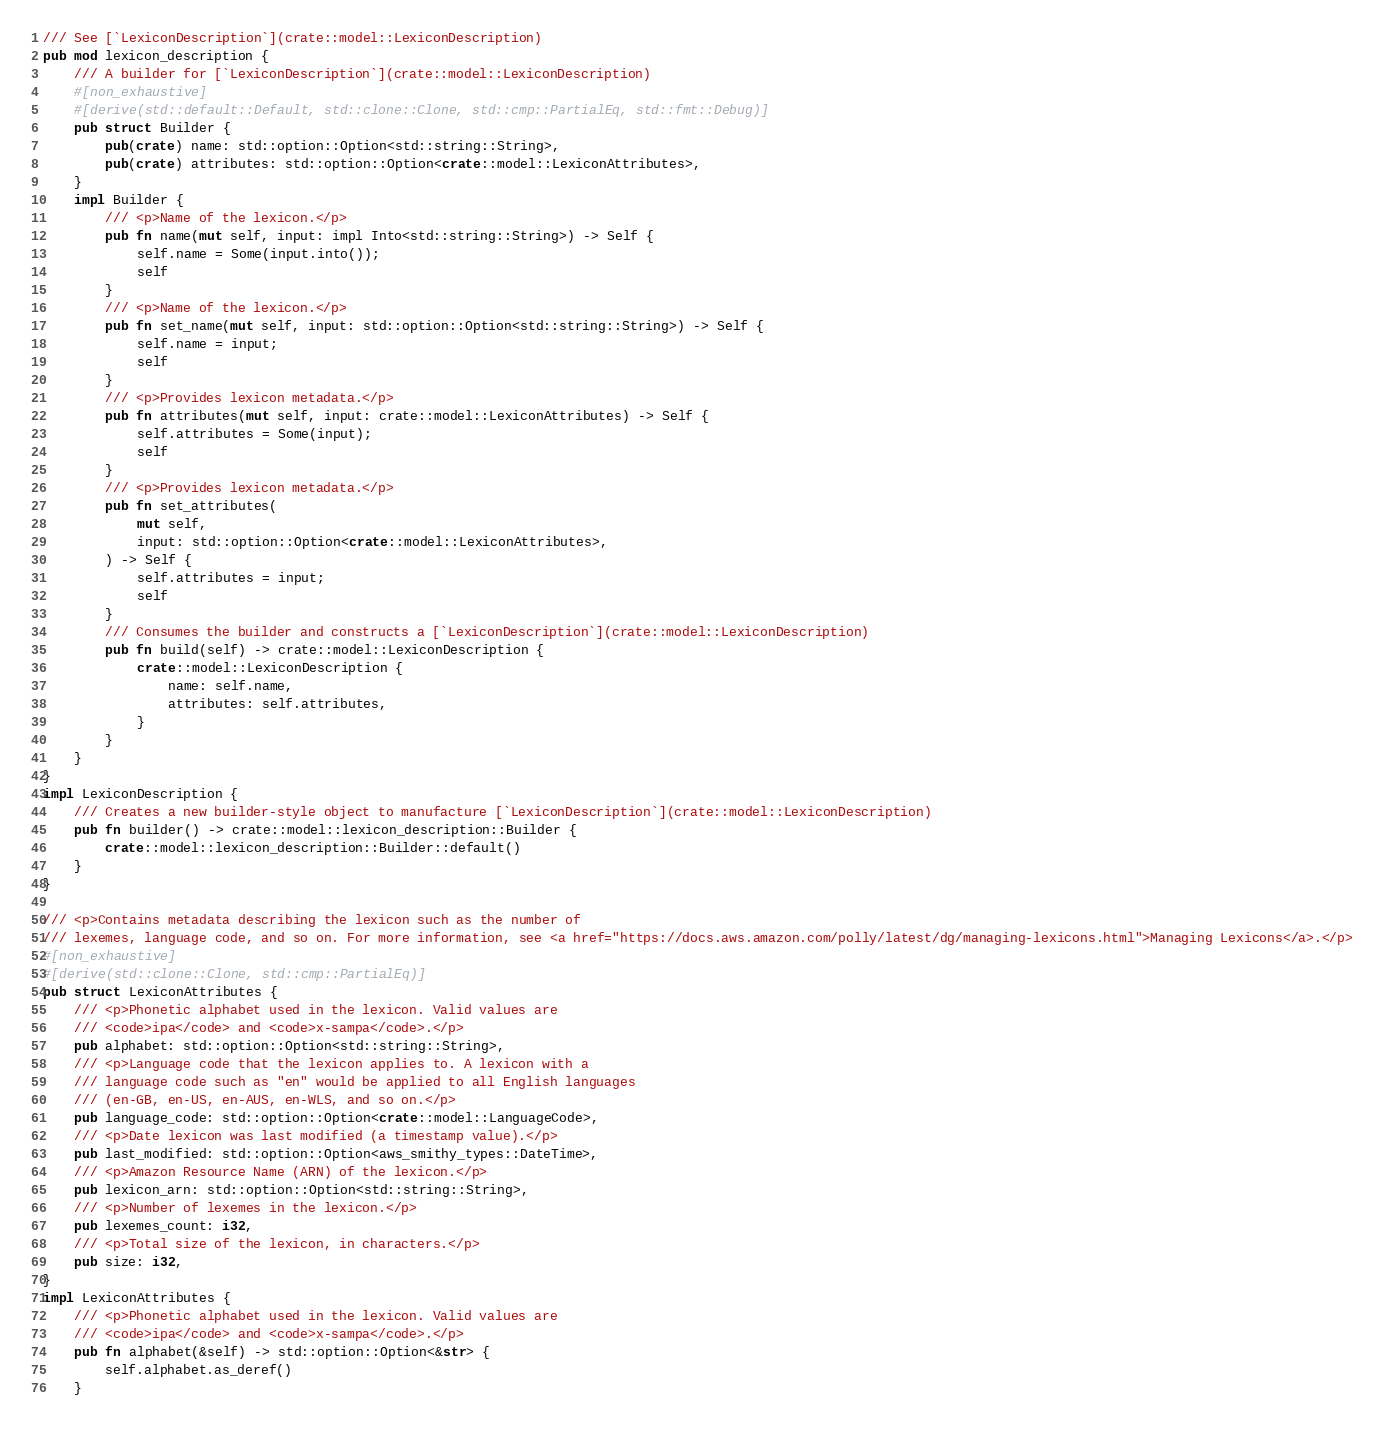<code> <loc_0><loc_0><loc_500><loc_500><_Rust_>/// See [`LexiconDescription`](crate::model::LexiconDescription)
pub mod lexicon_description {
    /// A builder for [`LexiconDescription`](crate::model::LexiconDescription)
    #[non_exhaustive]
    #[derive(std::default::Default, std::clone::Clone, std::cmp::PartialEq, std::fmt::Debug)]
    pub struct Builder {
        pub(crate) name: std::option::Option<std::string::String>,
        pub(crate) attributes: std::option::Option<crate::model::LexiconAttributes>,
    }
    impl Builder {
        /// <p>Name of the lexicon.</p>
        pub fn name(mut self, input: impl Into<std::string::String>) -> Self {
            self.name = Some(input.into());
            self
        }
        /// <p>Name of the lexicon.</p>
        pub fn set_name(mut self, input: std::option::Option<std::string::String>) -> Self {
            self.name = input;
            self
        }
        /// <p>Provides lexicon metadata.</p>
        pub fn attributes(mut self, input: crate::model::LexiconAttributes) -> Self {
            self.attributes = Some(input);
            self
        }
        /// <p>Provides lexicon metadata.</p>
        pub fn set_attributes(
            mut self,
            input: std::option::Option<crate::model::LexiconAttributes>,
        ) -> Self {
            self.attributes = input;
            self
        }
        /// Consumes the builder and constructs a [`LexiconDescription`](crate::model::LexiconDescription)
        pub fn build(self) -> crate::model::LexiconDescription {
            crate::model::LexiconDescription {
                name: self.name,
                attributes: self.attributes,
            }
        }
    }
}
impl LexiconDescription {
    /// Creates a new builder-style object to manufacture [`LexiconDescription`](crate::model::LexiconDescription)
    pub fn builder() -> crate::model::lexicon_description::Builder {
        crate::model::lexicon_description::Builder::default()
    }
}

/// <p>Contains metadata describing the lexicon such as the number of
/// lexemes, language code, and so on. For more information, see <a href="https://docs.aws.amazon.com/polly/latest/dg/managing-lexicons.html">Managing Lexicons</a>.</p>
#[non_exhaustive]
#[derive(std::clone::Clone, std::cmp::PartialEq)]
pub struct LexiconAttributes {
    /// <p>Phonetic alphabet used in the lexicon. Valid values are
    /// <code>ipa</code> and <code>x-sampa</code>.</p>
    pub alphabet: std::option::Option<std::string::String>,
    /// <p>Language code that the lexicon applies to. A lexicon with a
    /// language code such as "en" would be applied to all English languages
    /// (en-GB, en-US, en-AUS, en-WLS, and so on.</p>
    pub language_code: std::option::Option<crate::model::LanguageCode>,
    /// <p>Date lexicon was last modified (a timestamp value).</p>
    pub last_modified: std::option::Option<aws_smithy_types::DateTime>,
    /// <p>Amazon Resource Name (ARN) of the lexicon.</p>
    pub lexicon_arn: std::option::Option<std::string::String>,
    /// <p>Number of lexemes in the lexicon.</p>
    pub lexemes_count: i32,
    /// <p>Total size of the lexicon, in characters.</p>
    pub size: i32,
}
impl LexiconAttributes {
    /// <p>Phonetic alphabet used in the lexicon. Valid values are
    /// <code>ipa</code> and <code>x-sampa</code>.</p>
    pub fn alphabet(&self) -> std::option::Option<&str> {
        self.alphabet.as_deref()
    }</code> 